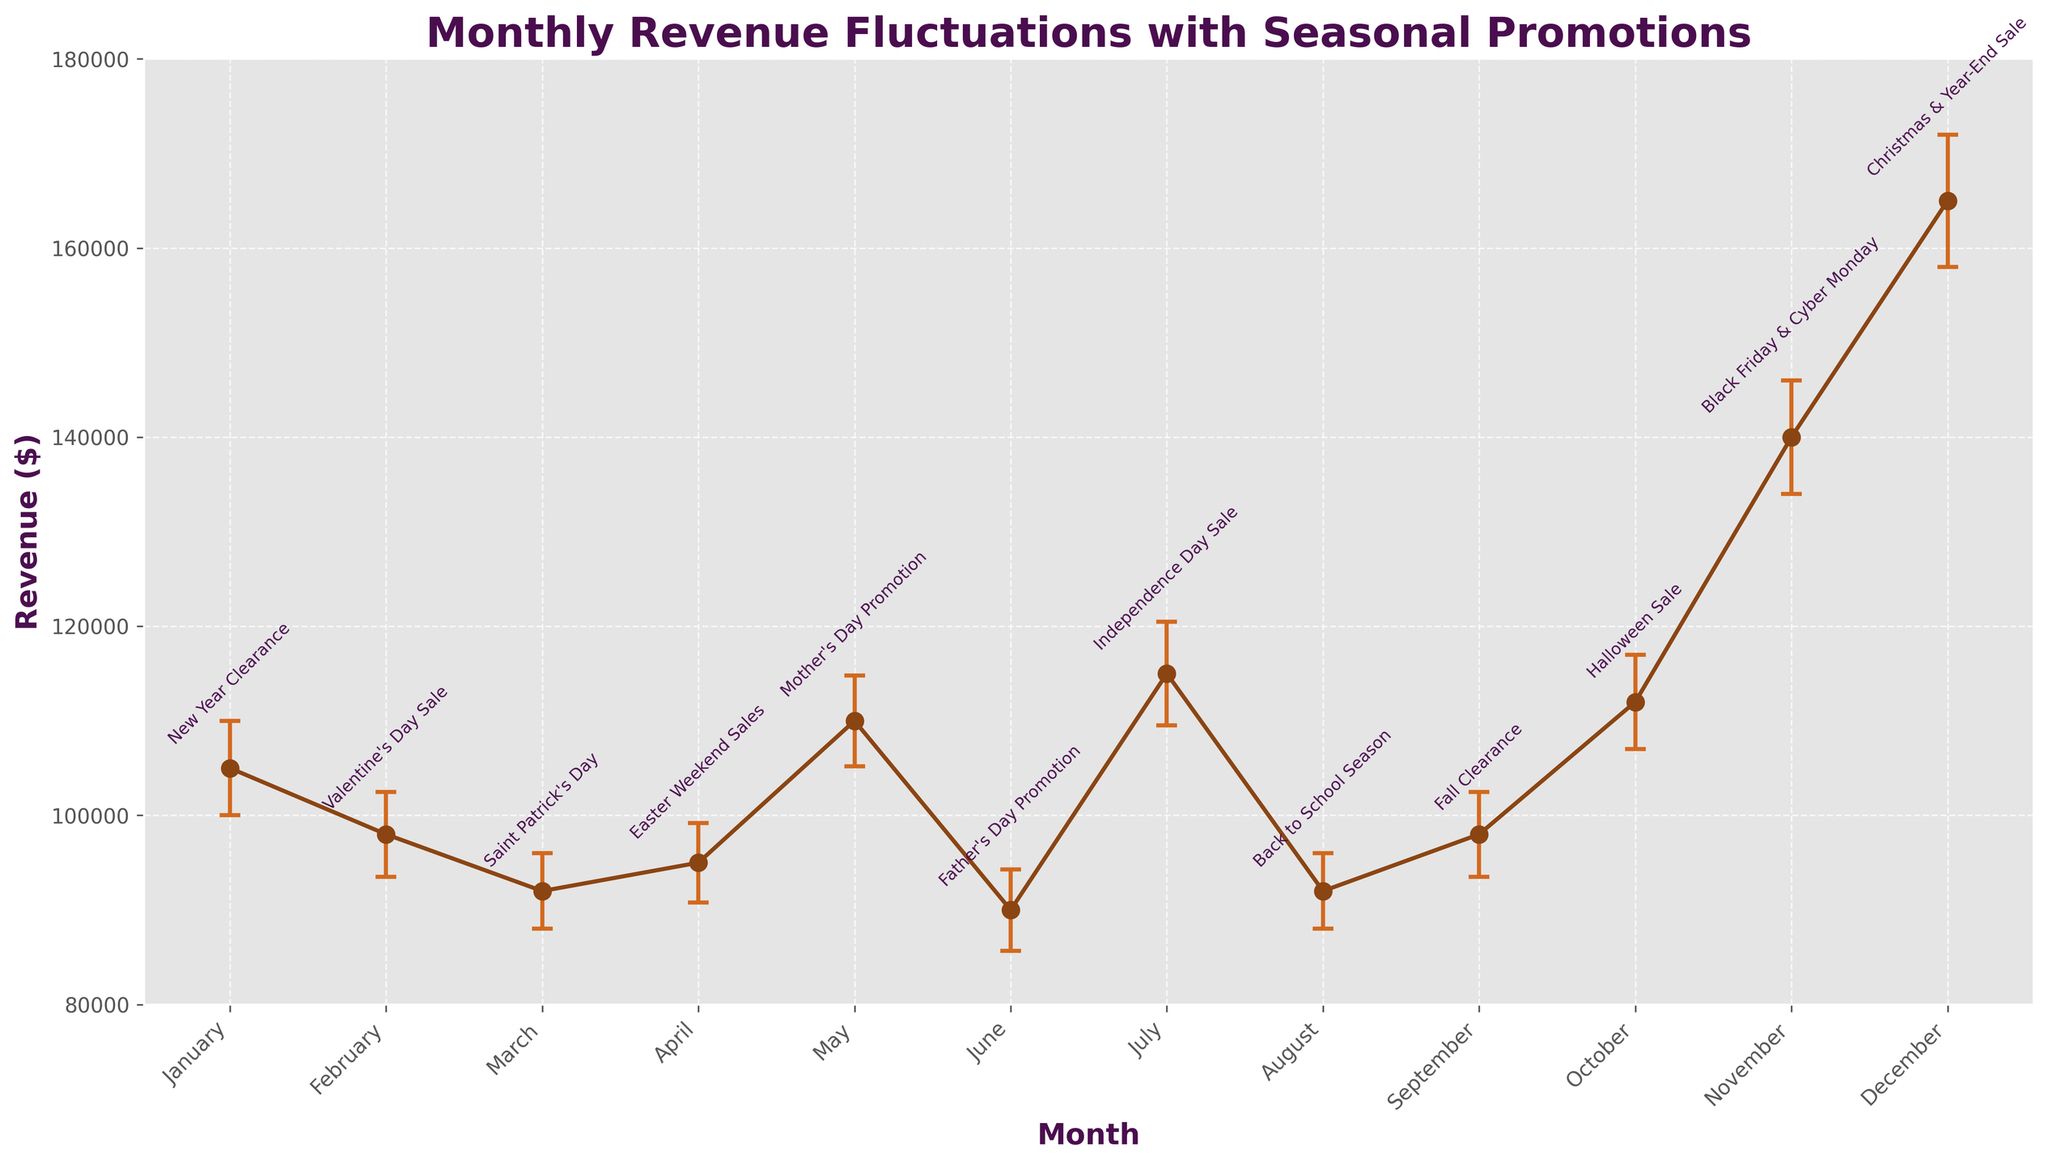What is the title of the plot? The title is located at the top of the plot in larger, bold font. It provides the context of the figure.
Answer: Monthly Revenue Fluctuations with Seasonal Promotions What month had the highest revenue? Look at the data points and the annotations for each month, identify the month with the highest Y-axis value.
Answer: December Which month had the lowest revenue? Examine the data points on the Y-axis and identify the month with the lowest Y-axis value.
Answer: June What is the general trend of revenue from January to December? By observing the line connecting the data points from January to December, one can identify whether the revenue is increasing, decreasing, or fluctuating.
Answer: Fluctuating with an increasing trend towards the end of the year What is the revenue difference between the highest and lowest months? Identify the highest and lowest revenue values from the Y-axis and subtract the lowest revenue from the highest revenue.
Answer: \(165,000 - 90,000 = 75,000\) How many data points are there on the plot? Count the number of data points, marked by circles, on the plot.
Answer: 12 What event is associated with the revenue spike in November? Locate the data point for November and read the annotation above it.
Answer: Black Friday & Cyber Monday Compare the revenue in May with the revenue in February. Which month had higher revenue? Identify the data points for May and February and compare their Y-axis values.
Answer: May What month has the smallest error bar? Examine the lengths of the vertical error bars for each data point and identify the month with the shortest one.
Answer: March, August How do the error bars indicate uncertainty in the revenue values? The error bars illustrate the possible range within which the actual revenue might lie, helping to visualize the uncertainty.
Answer: Indicate the range of possible values around the revenue measurements 